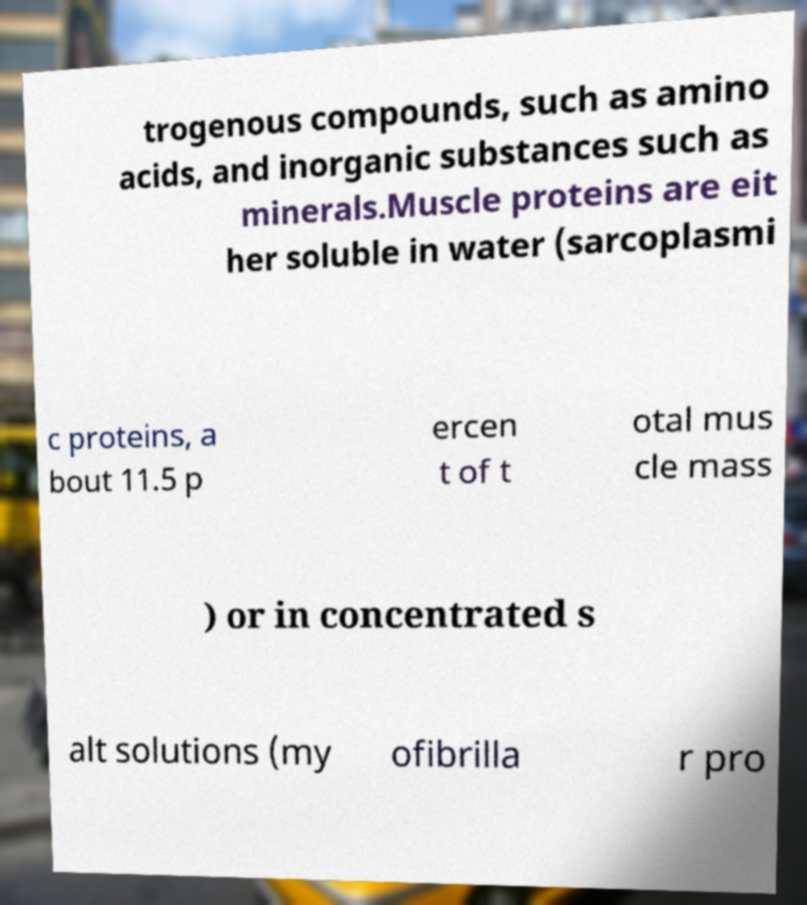There's text embedded in this image that I need extracted. Can you transcribe it verbatim? trogenous compounds, such as amino acids, and inorganic substances such as minerals.Muscle proteins are eit her soluble in water (sarcoplasmi c proteins, a bout 11.5 p ercen t of t otal mus cle mass ) or in concentrated s alt solutions (my ofibrilla r pro 